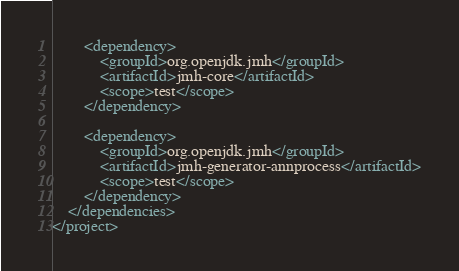Convert code to text. <code><loc_0><loc_0><loc_500><loc_500><_XML_>
        <dependency>
            <groupId>org.openjdk.jmh</groupId>
            <artifactId>jmh-core</artifactId>
            <scope>test</scope>
        </dependency>

        <dependency>
            <groupId>org.openjdk.jmh</groupId>
            <artifactId>jmh-generator-annprocess</artifactId>
            <scope>test</scope>
        </dependency>
    </dependencies>
</project>
</code> 